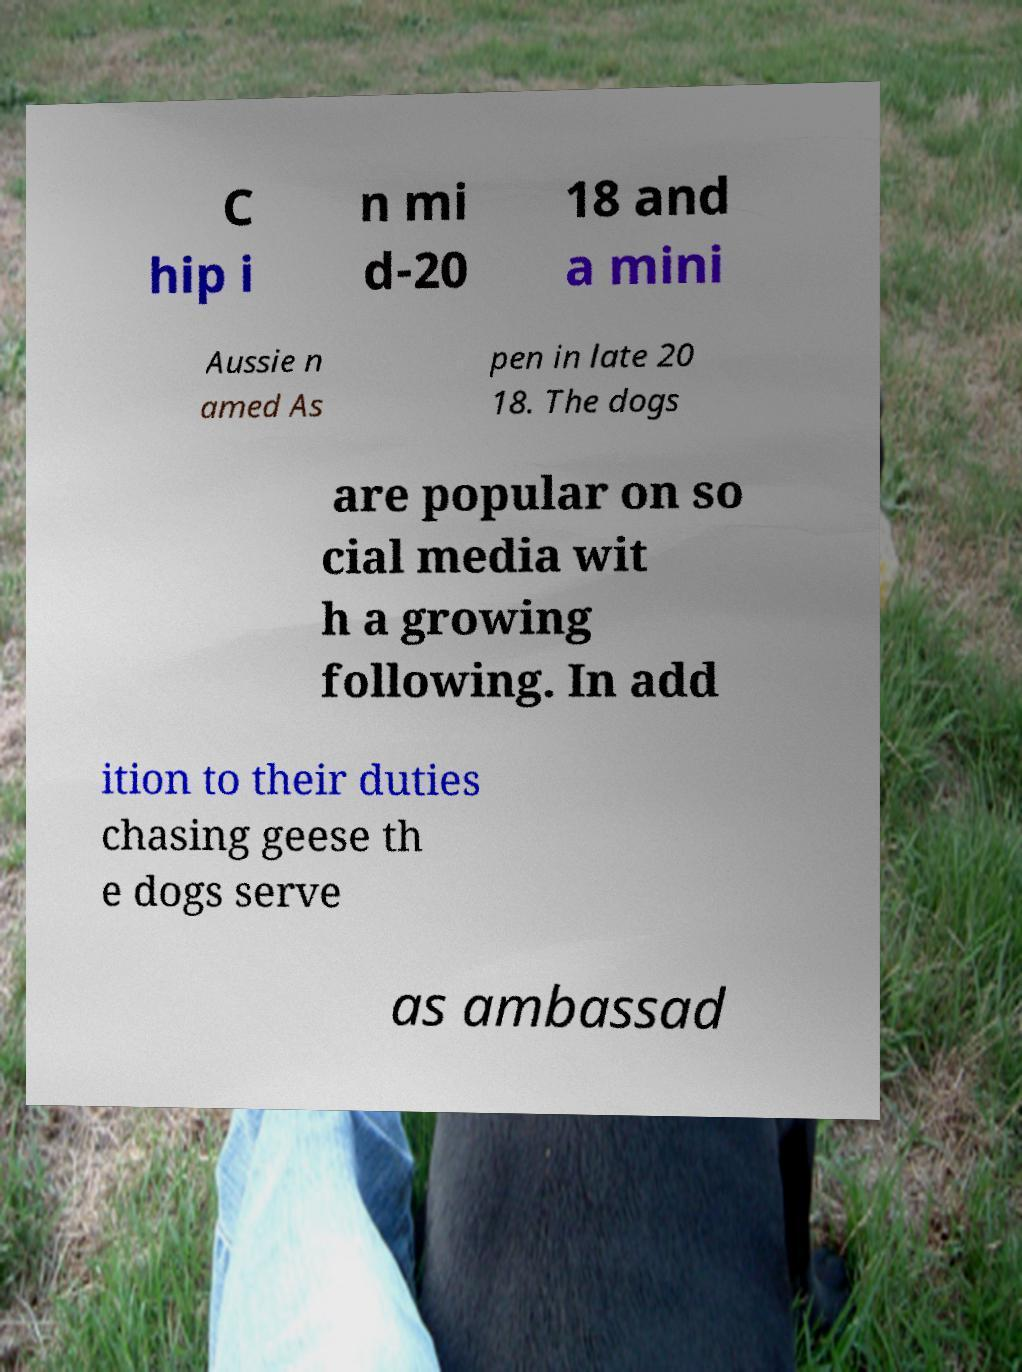Could you assist in decoding the text presented in this image and type it out clearly? C hip i n mi d-20 18 and a mini Aussie n amed As pen in late 20 18. The dogs are popular on so cial media wit h a growing following. In add ition to their duties chasing geese th e dogs serve as ambassad 